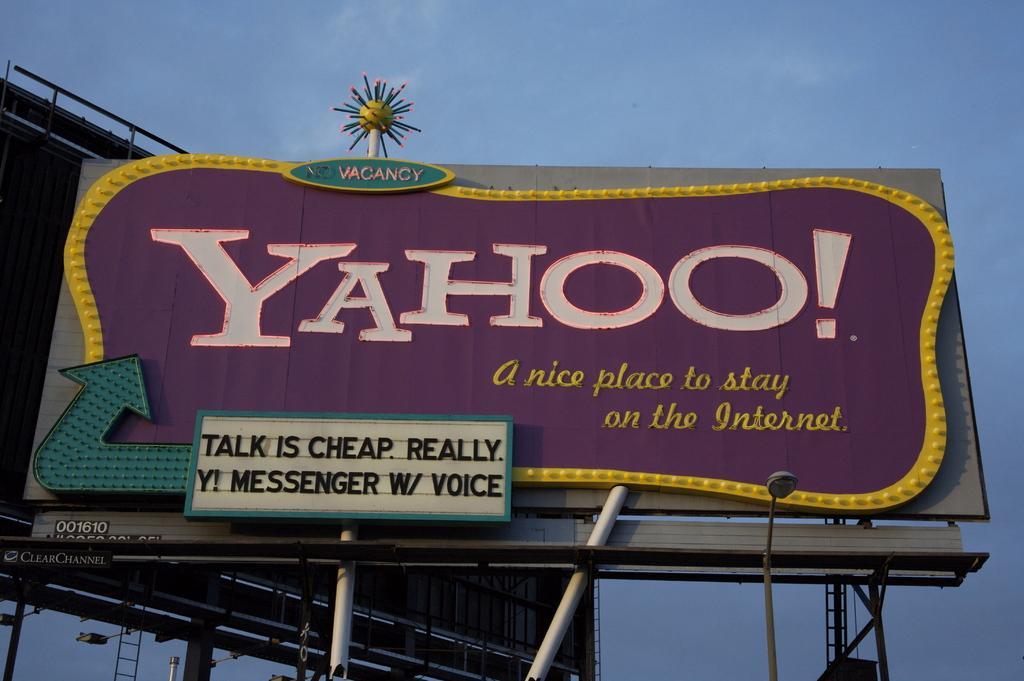Provide a one-sentence caption for the provided image. A Yahoo logo can be seen on a large sign with a blue sky in the background. 